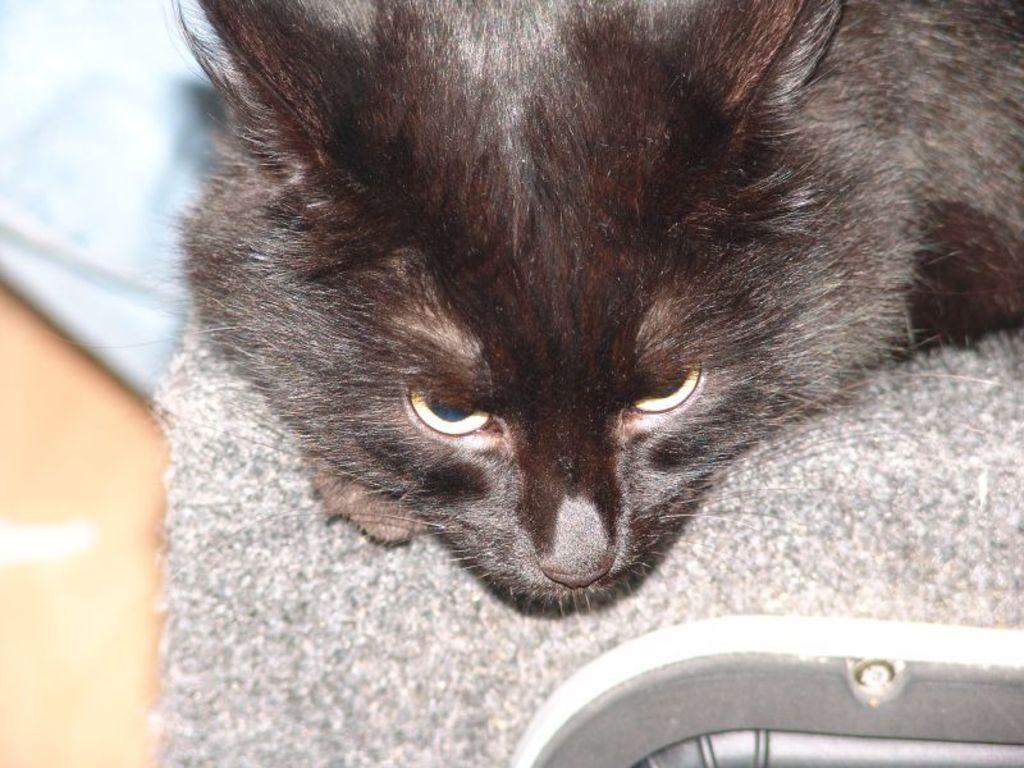Could you give a brief overview of what you see in this image? This is the zoom-in picture of a cat. 